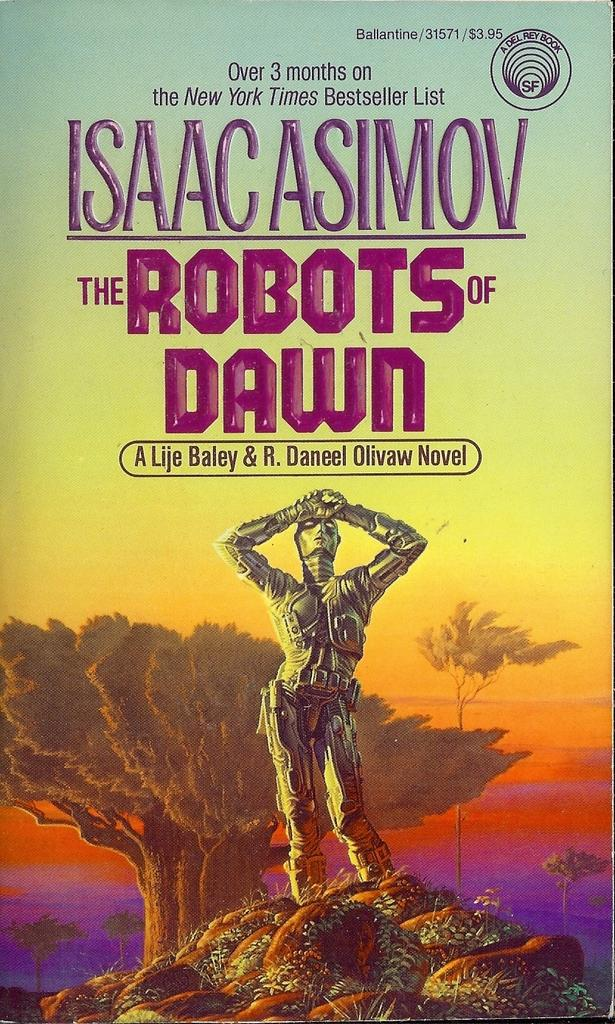What type of image is being described? The image is a poster. What is the main subject of the poster? There is a robot in the image. What is the robot standing on? The robot is standing on rocks. What other elements can be seen in the image? There are trees in the image. What else is featured on the poster besides the robot and trees? There are letters on the poster. What type of scent can be detected from the robot in the image? There is no indication of a scent in the image, as it is a visual representation of a robot standing on rocks. 